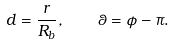Convert formula to latex. <formula><loc_0><loc_0><loc_500><loc_500>d = \frac { r } { R _ { b } } , \quad \theta = \phi - \pi .</formula> 